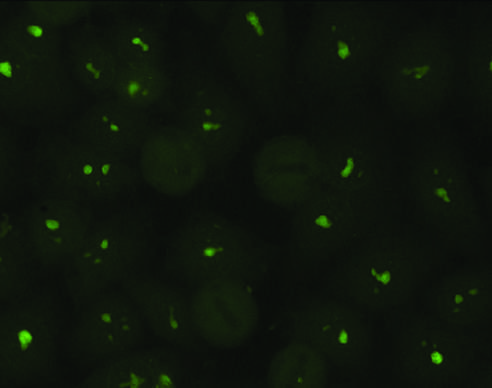s a nucleolar pattern typical of antibodies against nucleolar proteins?
Answer the question using a single word or phrase. Yes 